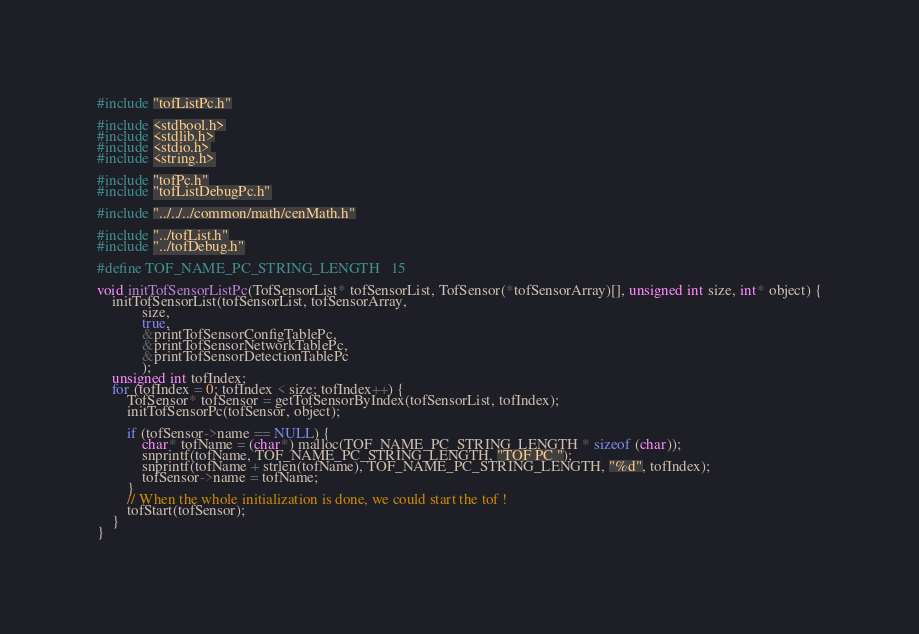Convert code to text. <code><loc_0><loc_0><loc_500><loc_500><_C_>#include "tofListPc.h"

#include <stdbool.h>
#include <stdlib.h>
#include <stdio.h>
#include <string.h>

#include "tofPc.h"
#include "tofListDebugPc.h"

#include "../../../common/math/cenMath.h"

#include "../tofList.h"
#include "../tofDebug.h"

#define TOF_NAME_PC_STRING_LENGTH   15

void initTofSensorListPc(TofSensorList* tofSensorList, TofSensor(*tofSensorArray)[], unsigned int size, int* object) {
    initTofSensorList(tofSensorList, tofSensorArray,
            size,
            true,
            &printTofSensorConfigTablePc,
            &printTofSensorNetworkTablePc,
            &printTofSensorDetectionTablePc
            );
    unsigned int tofIndex;
    for (tofIndex = 0; tofIndex < size; tofIndex++) {
        TofSensor* tofSensor = getTofSensorByIndex(tofSensorList, tofIndex);
        initTofSensorPc(tofSensor, object);

        if (tofSensor->name == NULL) {
            char* tofName = (char*) malloc(TOF_NAME_PC_STRING_LENGTH * sizeof (char));
            snprintf(tofName, TOF_NAME_PC_STRING_LENGTH, "TOF PC ");
            snprintf(tofName + strlen(tofName), TOF_NAME_PC_STRING_LENGTH, "%d", tofIndex);
            tofSensor->name = tofName;
        }
        // When the whole initialization is done, we could start the tof !
        tofStart(tofSensor);
    }
}</code> 